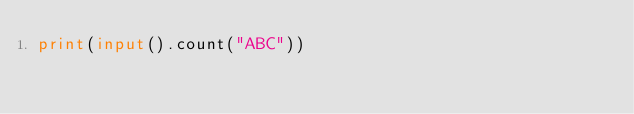Convert code to text. <code><loc_0><loc_0><loc_500><loc_500><_Python_>print(input().count("ABC"))</code> 